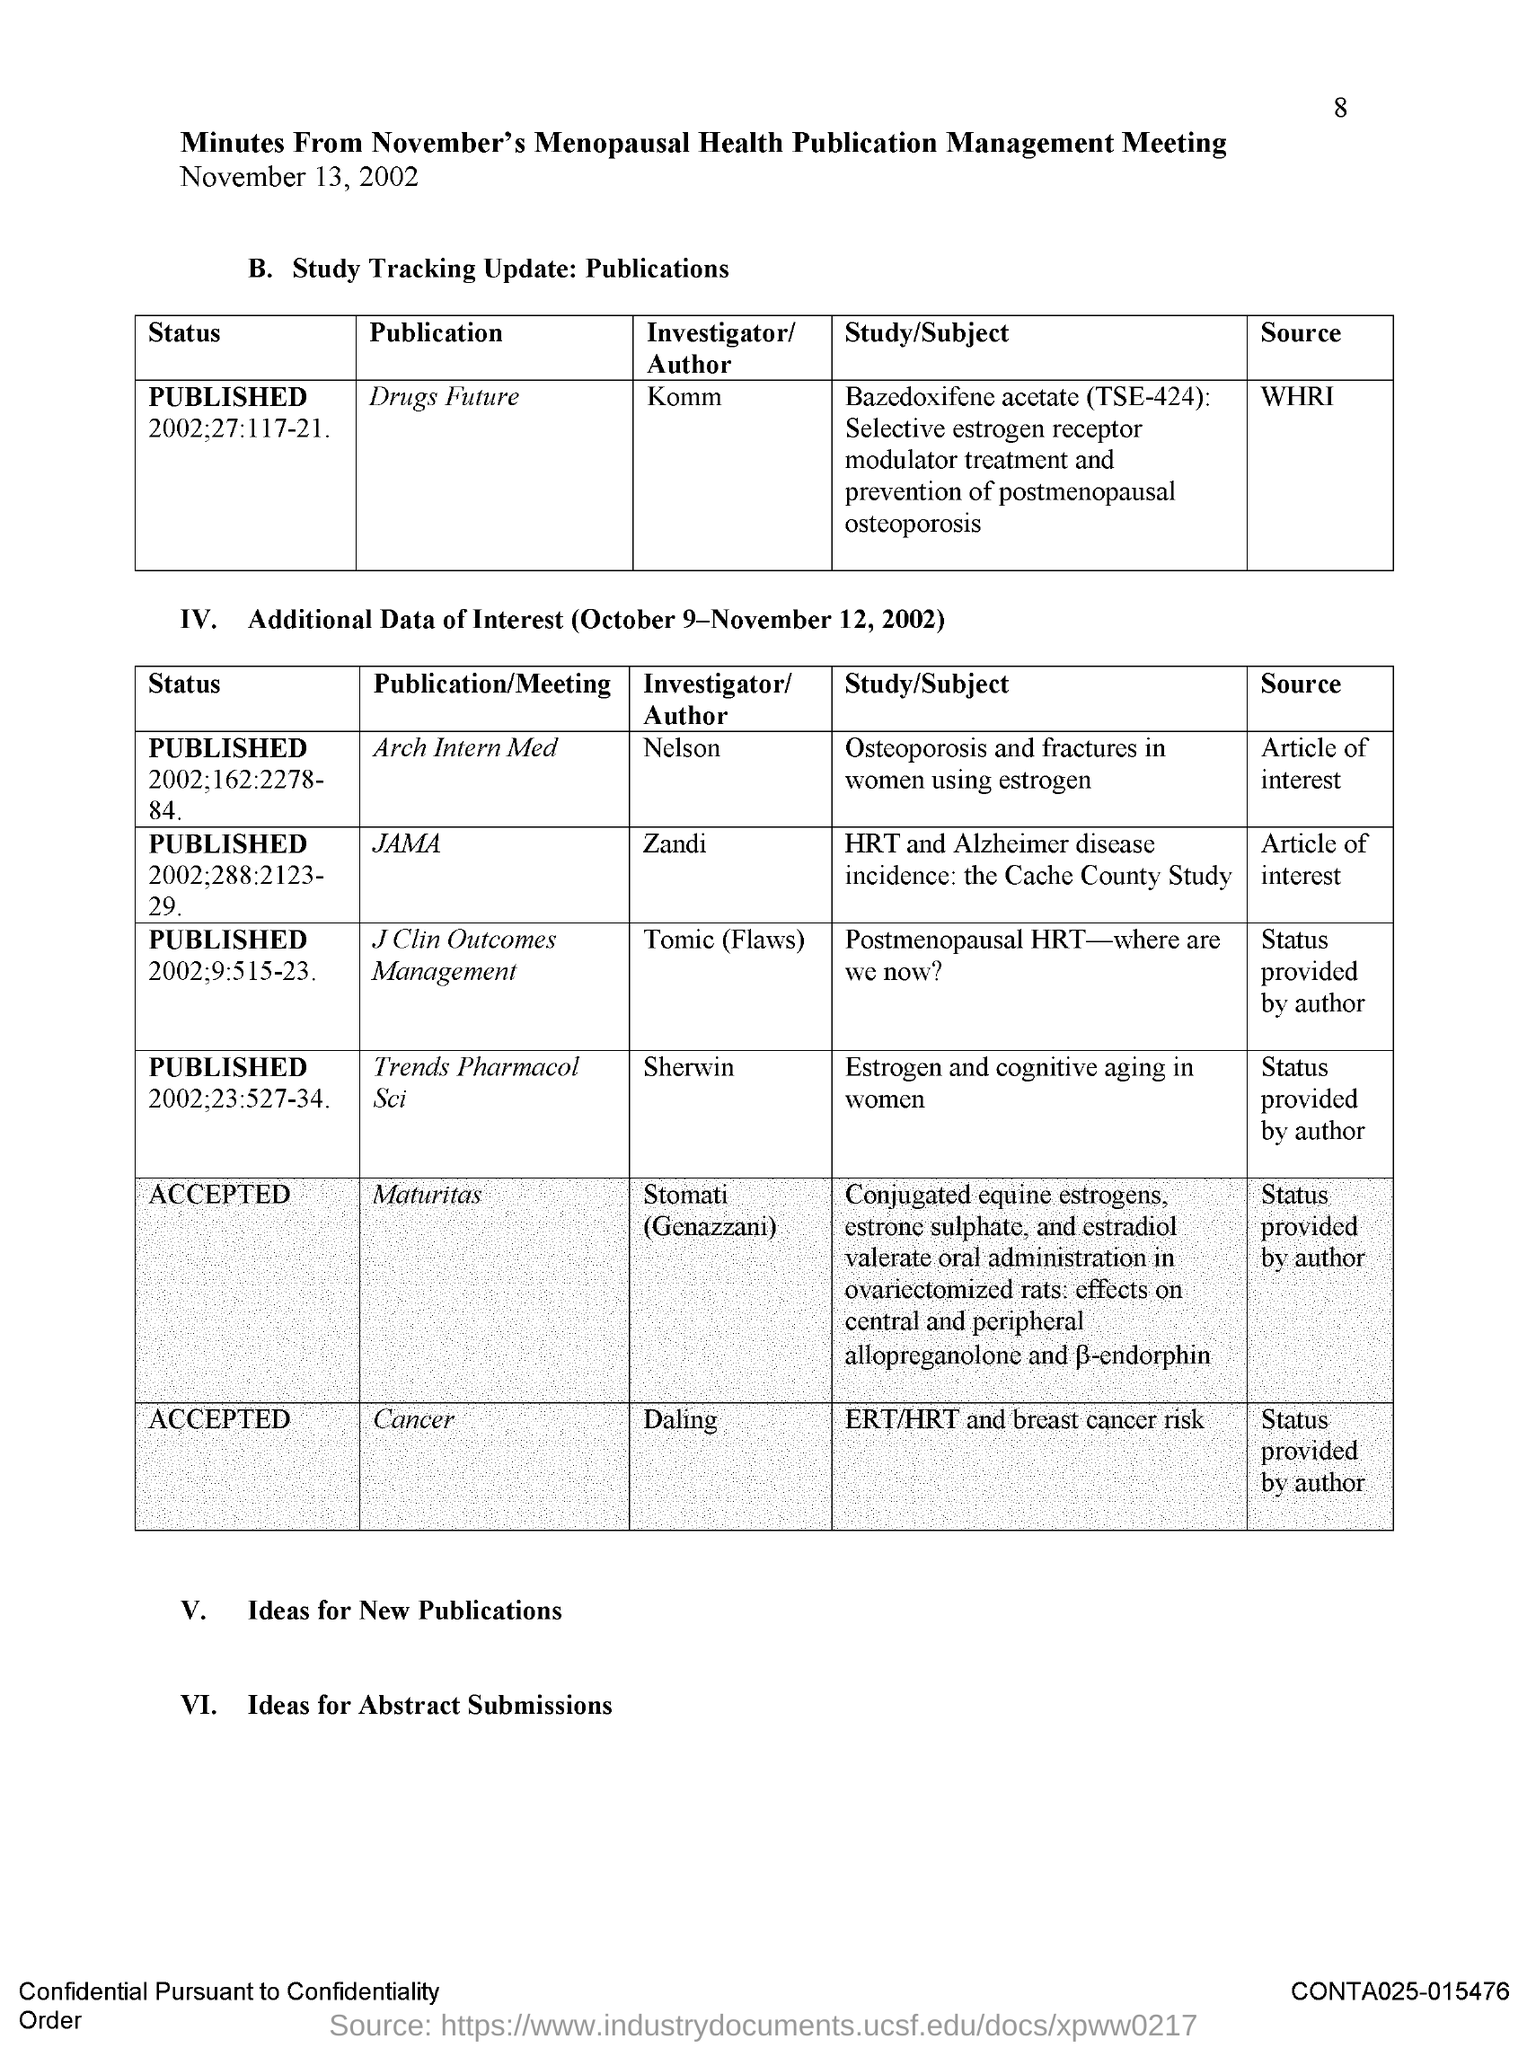Highlight a few significant elements in this photo. I, [name], am the author of the publication "Drugs Future. The author of the publication titled "Cancer" is Daling. The publication "Maturitas" has been accepted. This refers to the minutes of the meeting held in November for the purpose of managing the publication on menopausal health. The status of the publication "Cancer" has been accepted. 